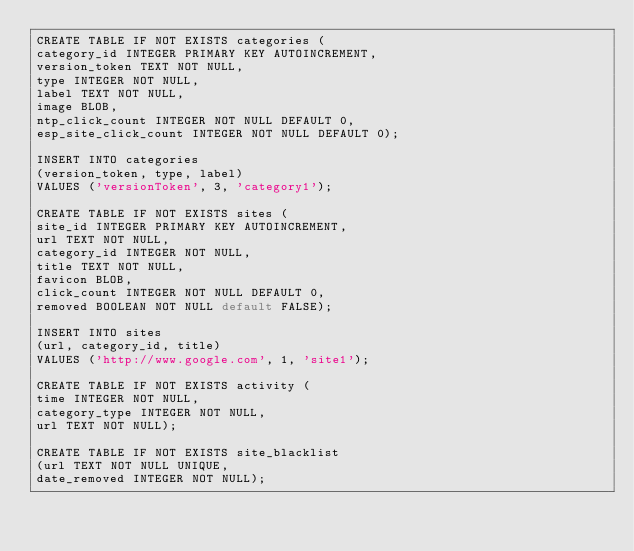Convert code to text. <code><loc_0><loc_0><loc_500><loc_500><_SQL_>CREATE TABLE IF NOT EXISTS categories (
category_id INTEGER PRIMARY KEY AUTOINCREMENT,
version_token TEXT NOT NULL,
type INTEGER NOT NULL,
label TEXT NOT NULL,
image BLOB,
ntp_click_count INTEGER NOT NULL DEFAULT 0,
esp_site_click_count INTEGER NOT NULL DEFAULT 0);

INSERT INTO categories
(version_token, type, label)
VALUES ('versionToken', 3, 'category1');

CREATE TABLE IF NOT EXISTS sites (
site_id INTEGER PRIMARY KEY AUTOINCREMENT,
url TEXT NOT NULL,
category_id INTEGER NOT NULL,
title TEXT NOT NULL,
favicon BLOB,
click_count INTEGER NOT NULL DEFAULT 0,
removed BOOLEAN NOT NULL default FALSE);

INSERT INTO sites
(url, category_id, title)
VALUES ('http://www.google.com', 1, 'site1');

CREATE TABLE IF NOT EXISTS activity (
time INTEGER NOT NULL,
category_type INTEGER NOT NULL,
url TEXT NOT NULL);

CREATE TABLE IF NOT EXISTS site_blacklist
(url TEXT NOT NULL UNIQUE,
date_removed INTEGER NOT NULL);
</code> 